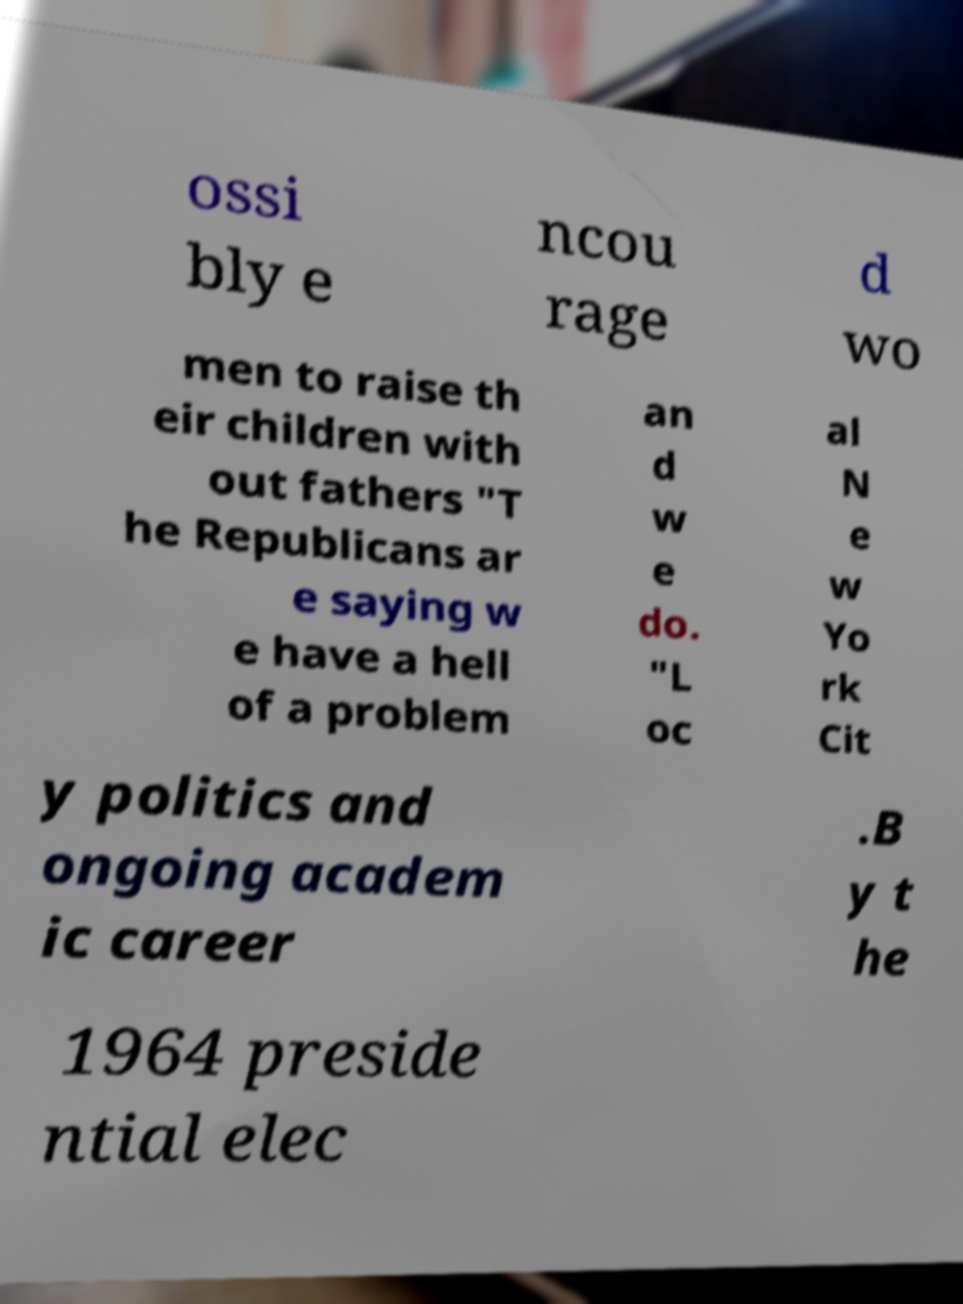Please identify and transcribe the text found in this image. ossi bly e ncou rage d wo men to raise th eir children with out fathers "T he Republicans ar e saying w e have a hell of a problem an d w e do. "L oc al N e w Yo rk Cit y politics and ongoing academ ic career .B y t he 1964 preside ntial elec 